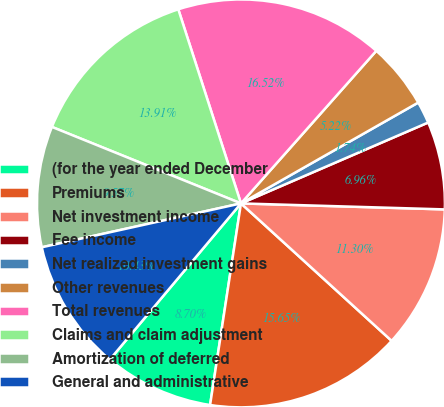Convert chart. <chart><loc_0><loc_0><loc_500><loc_500><pie_chart><fcel>(for the year ended December<fcel>Premiums<fcel>Net investment income<fcel>Fee income<fcel>Net realized investment gains<fcel>Other revenues<fcel>Total revenues<fcel>Claims and claim adjustment<fcel>Amortization of deferred<fcel>General and administrative<nl><fcel>8.7%<fcel>15.65%<fcel>11.3%<fcel>6.96%<fcel>1.74%<fcel>5.22%<fcel>16.52%<fcel>13.91%<fcel>9.57%<fcel>10.43%<nl></chart> 